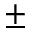<formula> <loc_0><loc_0><loc_500><loc_500>\pm</formula> 